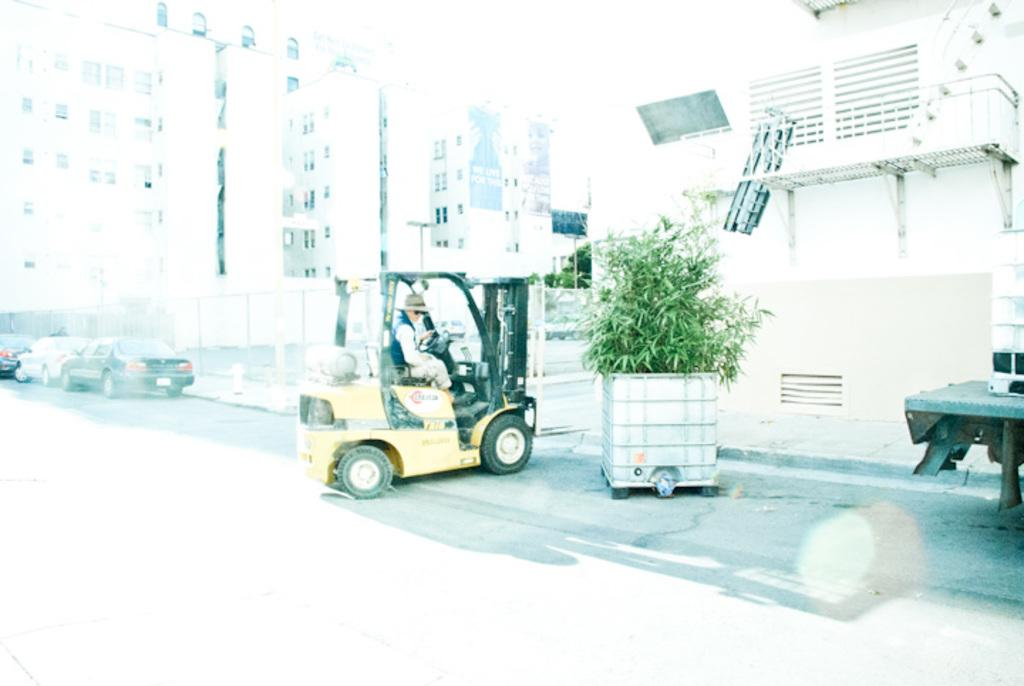What is the main subject of the image? There is a person driving a four-wheeler in the image. What can be seen in the background of the image? There are buildings and cars in the background of the image. Can you tell me how many tigers are walking alongside the four-wheeler in the image? There are no tigers present in the image; it features a person driving a four-wheeler with buildings and cars in the background. What suggestion does the person driving the four-wheeler make to the viewer in the image? The image does not contain any text or dialogue, so it is not possible to determine any suggestions made by the person driving the four-wheeler. 